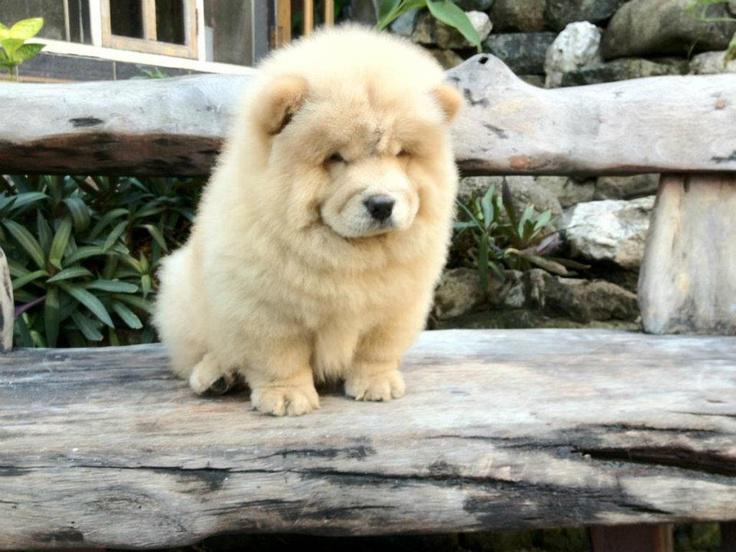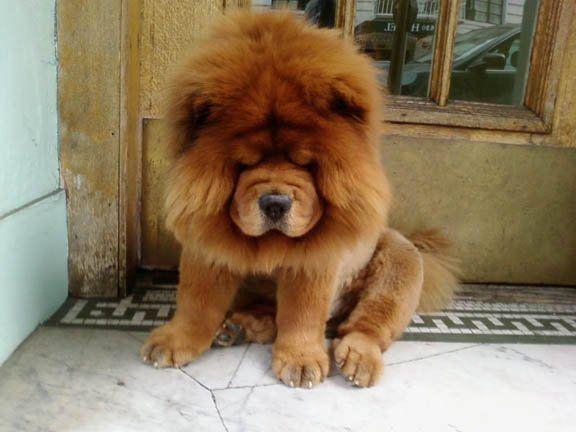The first image is the image on the left, the second image is the image on the right. Evaluate the accuracy of this statement regarding the images: "One chow is an adult dog with a flat forward-turned face and thick red orange mane, and no chows have blackish body fur.". Is it true? Answer yes or no. Yes. 